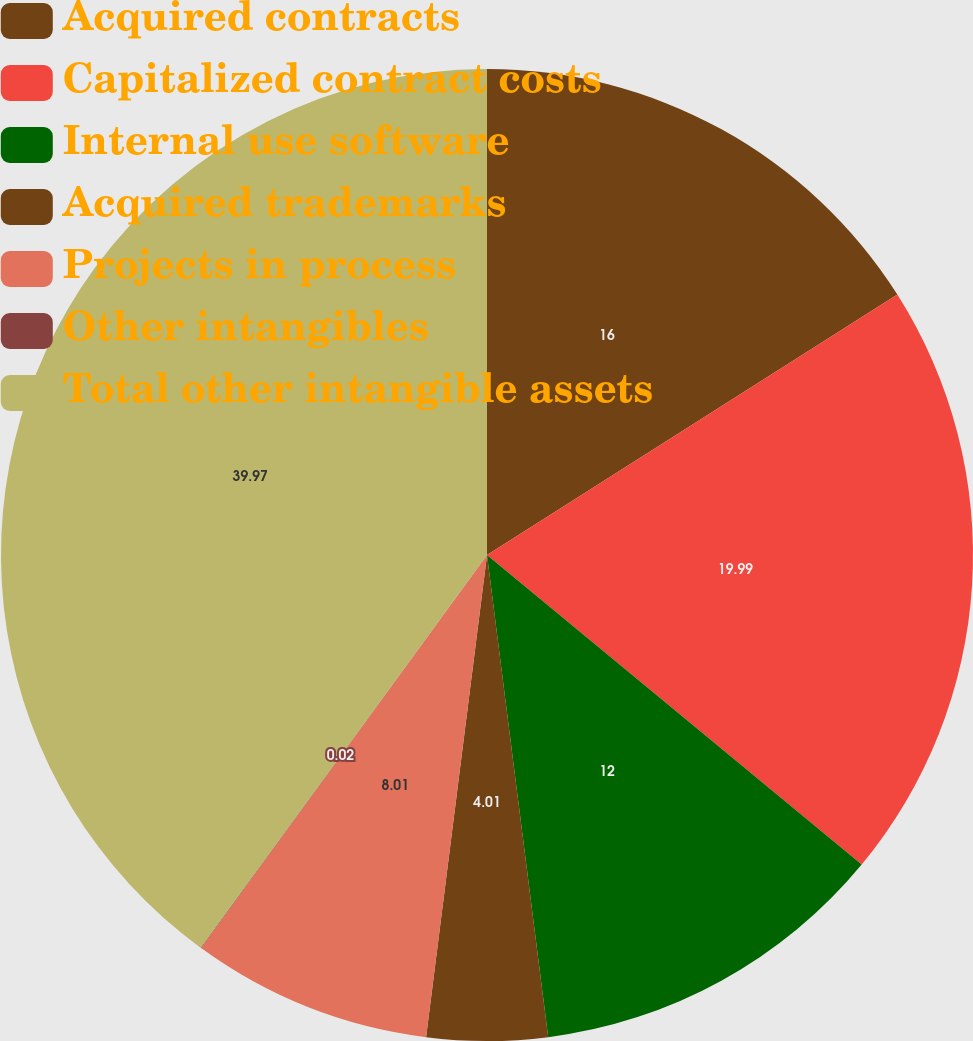<chart> <loc_0><loc_0><loc_500><loc_500><pie_chart><fcel>Acquired contracts<fcel>Capitalized contract costs<fcel>Internal use software<fcel>Acquired trademarks<fcel>Projects in process<fcel>Other intangibles<fcel>Total other intangible assets<nl><fcel>16.0%<fcel>19.99%<fcel>12.0%<fcel>4.01%<fcel>8.01%<fcel>0.02%<fcel>39.97%<nl></chart> 